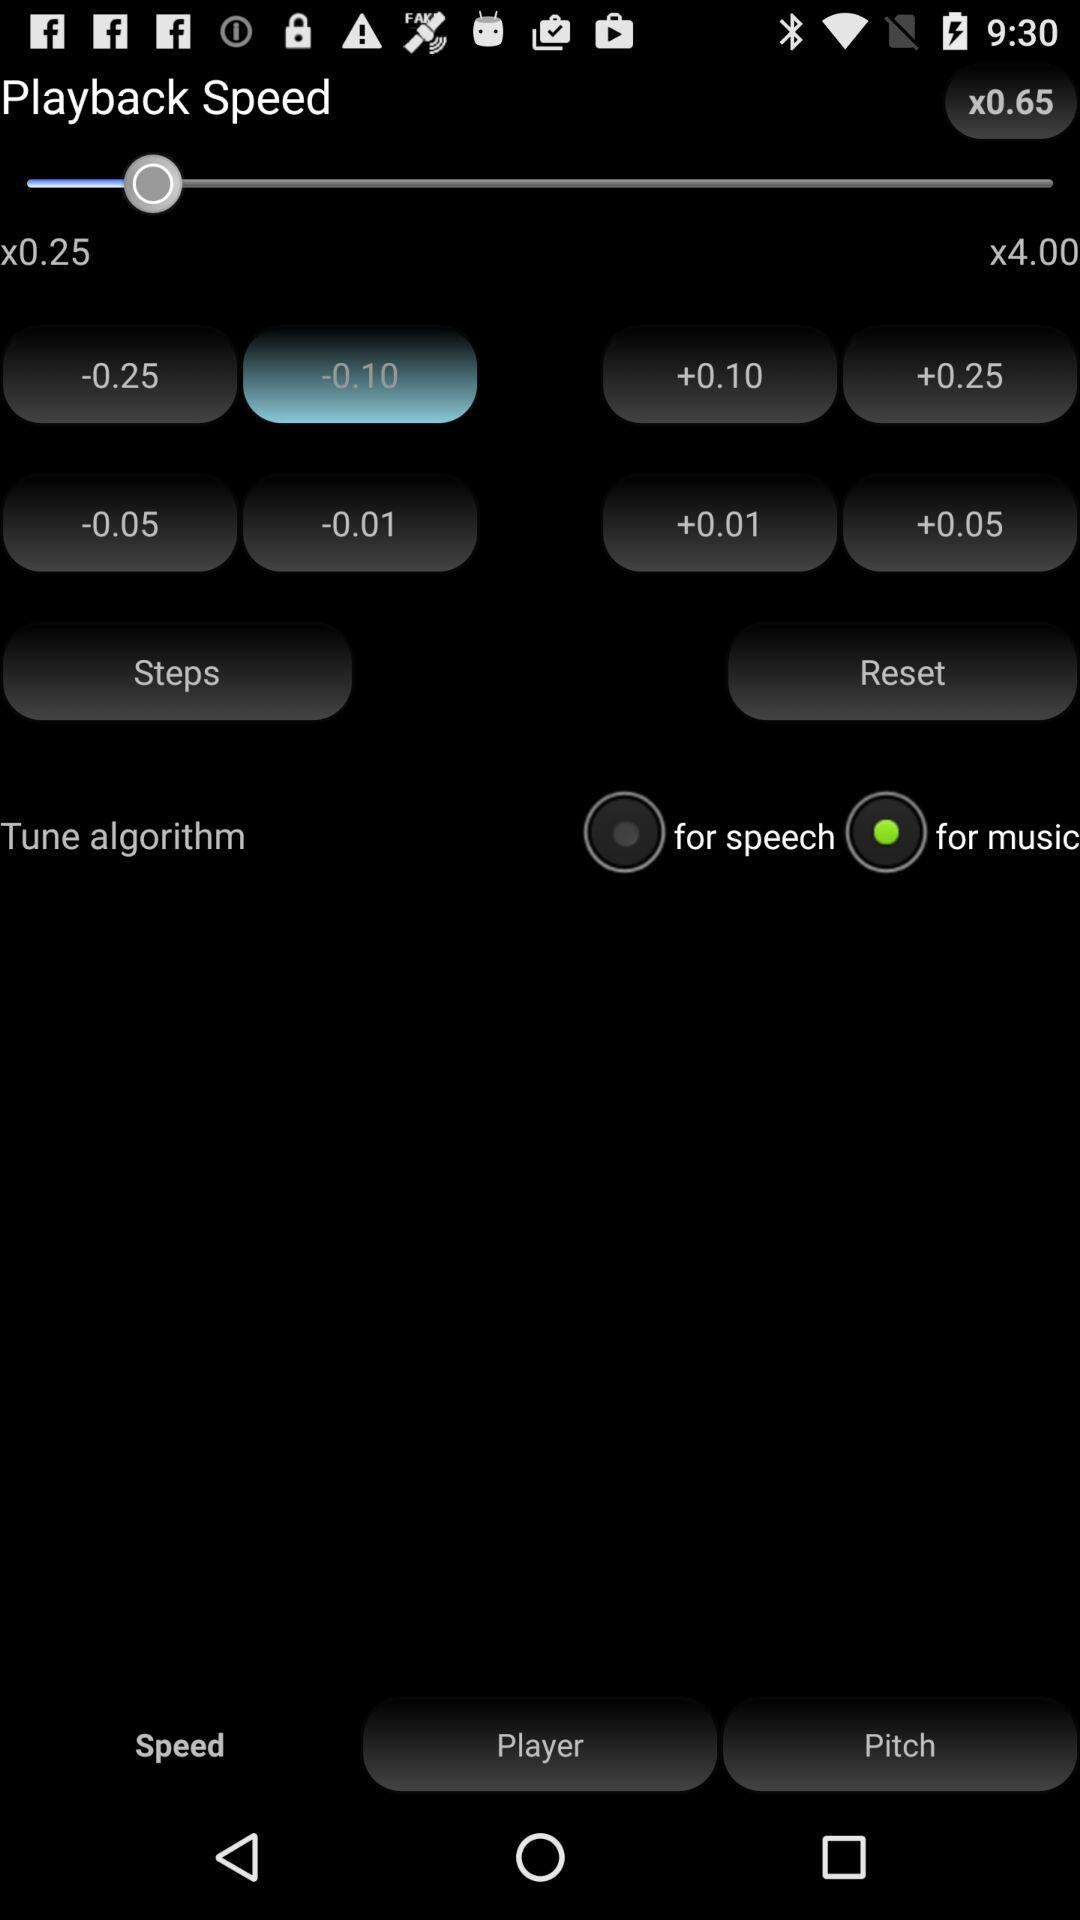Which option is selected in "Tune algorithm"? The selected option is "for music". 